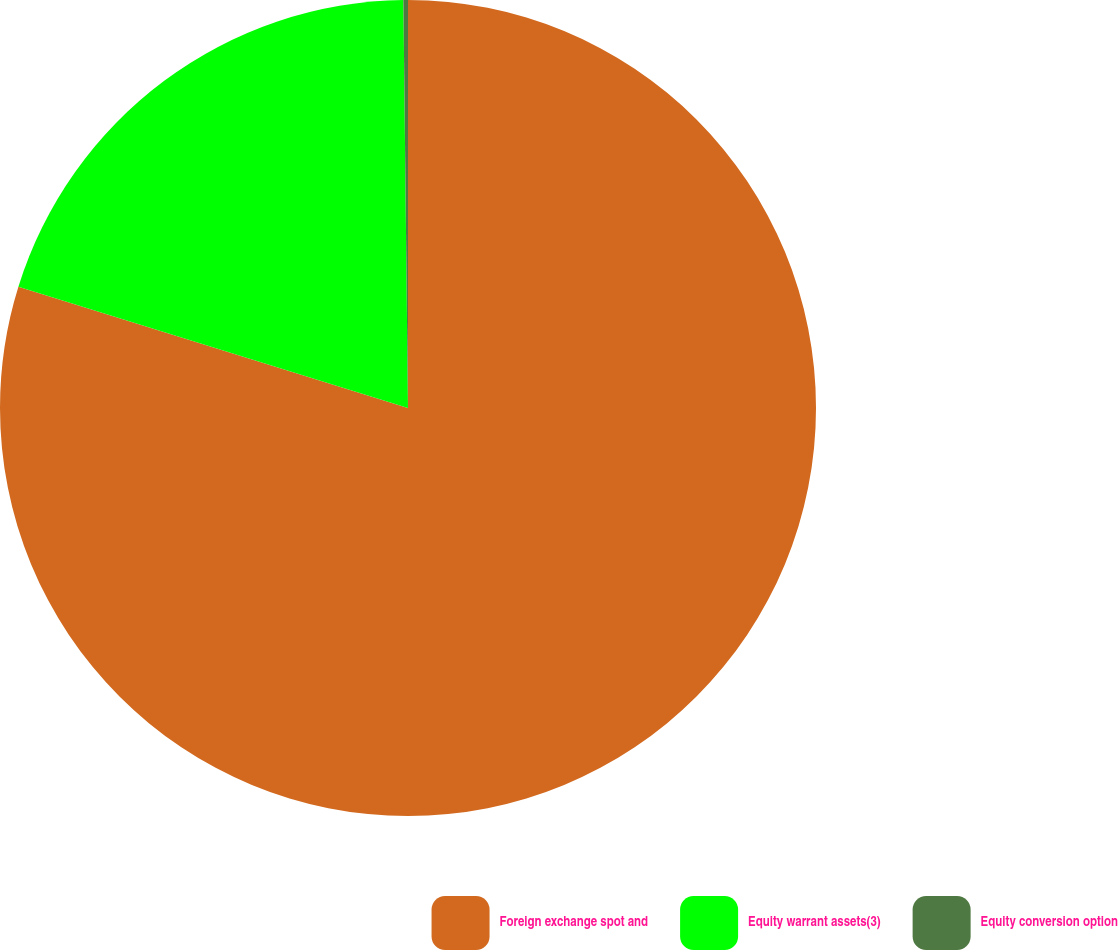Convert chart. <chart><loc_0><loc_0><loc_500><loc_500><pie_chart><fcel>Foreign exchange spot and<fcel>Equity warrant assets(3)<fcel>Equity conversion option<nl><fcel>79.79%<fcel>20.02%<fcel>0.18%<nl></chart> 